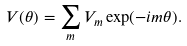Convert formula to latex. <formula><loc_0><loc_0><loc_500><loc_500>V ( \theta ) = \sum _ { m } V _ { m } \exp ( - i m \theta ) .</formula> 